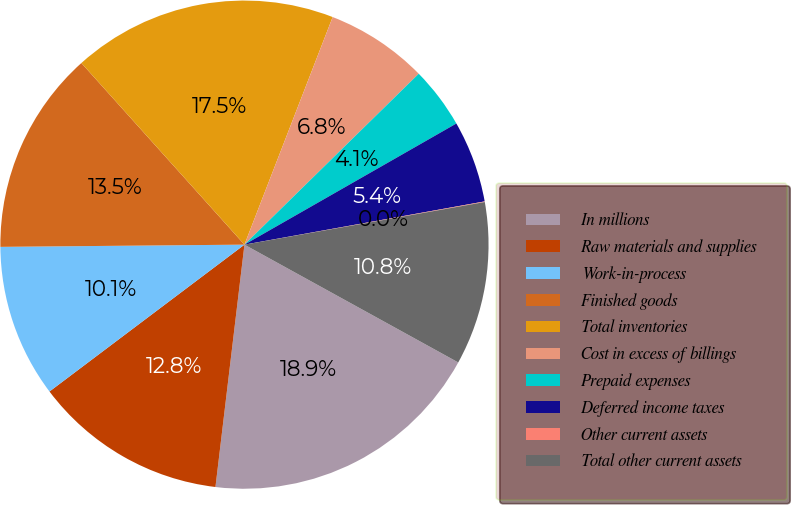Convert chart. <chart><loc_0><loc_0><loc_500><loc_500><pie_chart><fcel>In millions<fcel>Raw materials and supplies<fcel>Work-in-process<fcel>Finished goods<fcel>Total inventories<fcel>Cost in excess of billings<fcel>Prepaid expenses<fcel>Deferred income taxes<fcel>Other current assets<fcel>Total other current assets<nl><fcel>18.88%<fcel>12.83%<fcel>10.13%<fcel>13.5%<fcel>17.53%<fcel>6.77%<fcel>4.08%<fcel>5.43%<fcel>0.04%<fcel>10.81%<nl></chart> 